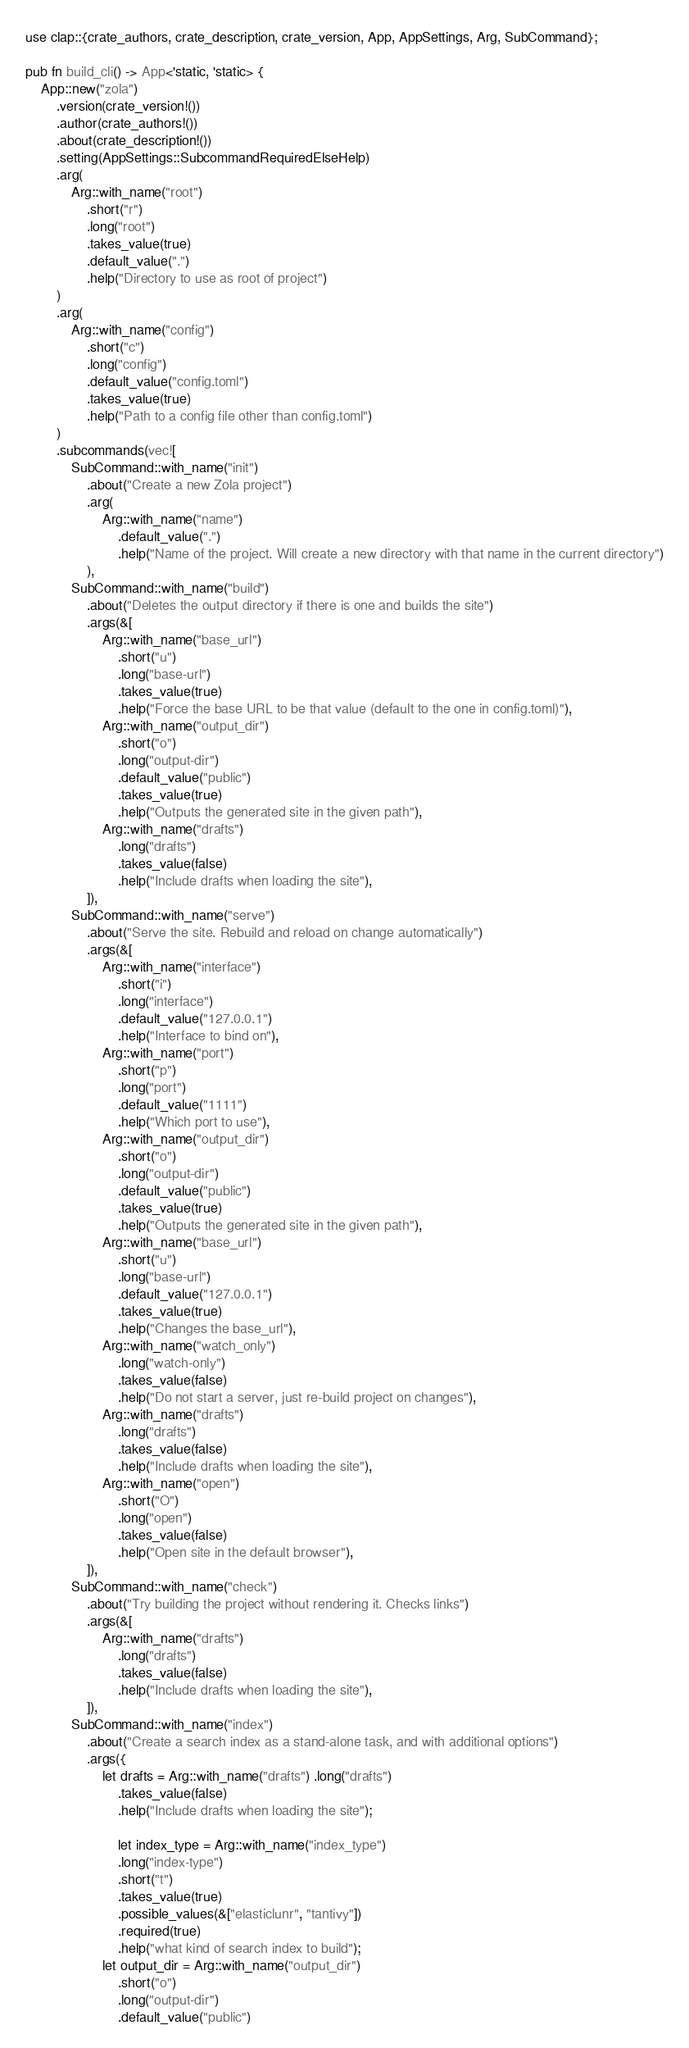<code> <loc_0><loc_0><loc_500><loc_500><_Rust_>use clap::{crate_authors, crate_description, crate_version, App, AppSettings, Arg, SubCommand};

pub fn build_cli() -> App<'static, 'static> {
    App::new("zola")
        .version(crate_version!())
        .author(crate_authors!())
        .about(crate_description!())
        .setting(AppSettings::SubcommandRequiredElseHelp)
        .arg(
            Arg::with_name("root")
                .short("r")
                .long("root")
                .takes_value(true)
                .default_value(".")
                .help("Directory to use as root of project")
        )
        .arg(
            Arg::with_name("config")
                .short("c")
                .long("config")
                .default_value("config.toml")
                .takes_value(true)
                .help("Path to a config file other than config.toml")
        )
        .subcommands(vec![
            SubCommand::with_name("init")
                .about("Create a new Zola project")
                .arg(
                    Arg::with_name("name")
                        .default_value(".")
                        .help("Name of the project. Will create a new directory with that name in the current directory")
                ),
            SubCommand::with_name("build")
                .about("Deletes the output directory if there is one and builds the site")
                .args(&[
                    Arg::with_name("base_url")
                        .short("u")
                        .long("base-url")
                        .takes_value(true)
                        .help("Force the base URL to be that value (default to the one in config.toml)"),
                    Arg::with_name("output_dir")
                        .short("o")
                        .long("output-dir")
                        .default_value("public")
                        .takes_value(true)
                        .help("Outputs the generated site in the given path"),
                    Arg::with_name("drafts")
                        .long("drafts")
                        .takes_value(false)
                        .help("Include drafts when loading the site"),
                ]),
            SubCommand::with_name("serve")
                .about("Serve the site. Rebuild and reload on change automatically")
                .args(&[
                    Arg::with_name("interface")
                        .short("i")
                        .long("interface")
                        .default_value("127.0.0.1")
                        .help("Interface to bind on"),
                    Arg::with_name("port")
                        .short("p")
                        .long("port")
                        .default_value("1111")
                        .help("Which port to use"),
                    Arg::with_name("output_dir")
                        .short("o")
                        .long("output-dir")
                        .default_value("public")
                        .takes_value(true)
                        .help("Outputs the generated site in the given path"),
                    Arg::with_name("base_url")
                        .short("u")
                        .long("base-url")
                        .default_value("127.0.0.1")
                        .takes_value(true)
                        .help("Changes the base_url"),
                    Arg::with_name("watch_only")
                        .long("watch-only")
                        .takes_value(false)
                        .help("Do not start a server, just re-build project on changes"),
                    Arg::with_name("drafts")
                        .long("drafts")
                        .takes_value(false)
                        .help("Include drafts when loading the site"),
                    Arg::with_name("open")
                        .short("O")
                        .long("open")
                        .takes_value(false)
                        .help("Open site in the default browser"),
                ]),
            SubCommand::with_name("check")
                .about("Try building the project without rendering it. Checks links")
                .args(&[
                    Arg::with_name("drafts")
                        .long("drafts")
                        .takes_value(false)
                        .help("Include drafts when loading the site"),
                ]),
            SubCommand::with_name("index")
                .about("Create a search index as a stand-alone task, and with additional options")
                .args({
                    let drafts = Arg::with_name("drafts") .long("drafts")
                        .takes_value(false)
                        .help("Include drafts when loading the site");

                        let index_type = Arg::with_name("index_type")
                        .long("index-type")
                        .short("t")
                        .takes_value(true)
                        .possible_values(&["elasticlunr", "tantivy"])
                        .required(true)
                        .help("what kind of search index to build");
                    let output_dir = Arg::with_name("output_dir")
                        .short("o")
                        .long("output-dir")
                        .default_value("public")</code> 